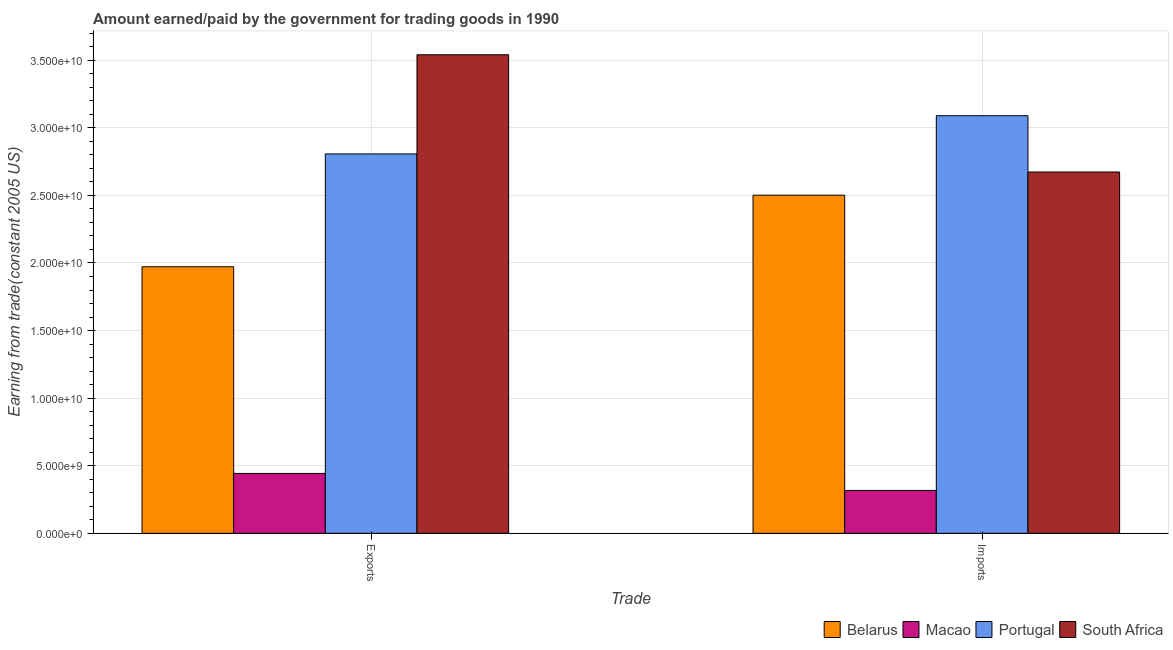How many different coloured bars are there?
Your response must be concise. 4. How many groups of bars are there?
Offer a very short reply. 2. Are the number of bars per tick equal to the number of legend labels?
Keep it short and to the point. Yes. Are the number of bars on each tick of the X-axis equal?
Give a very brief answer. Yes. How many bars are there on the 1st tick from the left?
Offer a very short reply. 4. What is the label of the 2nd group of bars from the left?
Keep it short and to the point. Imports. What is the amount paid for imports in Belarus?
Offer a very short reply. 2.50e+1. Across all countries, what is the maximum amount paid for imports?
Make the answer very short. 3.09e+1. Across all countries, what is the minimum amount paid for imports?
Offer a very short reply. 3.17e+09. In which country was the amount paid for imports minimum?
Make the answer very short. Macao. What is the total amount paid for imports in the graph?
Give a very brief answer. 8.58e+1. What is the difference between the amount paid for imports in Portugal and that in Belarus?
Offer a terse response. 5.88e+09. What is the difference between the amount paid for imports in Belarus and the amount earned from exports in Portugal?
Provide a succinct answer. -3.05e+09. What is the average amount earned from exports per country?
Provide a succinct answer. 2.19e+1. What is the difference between the amount earned from exports and amount paid for imports in Macao?
Provide a short and direct response. 1.26e+09. What is the ratio of the amount earned from exports in Belarus to that in South Africa?
Provide a succinct answer. 0.56. Is the amount paid for imports in South Africa less than that in Macao?
Make the answer very short. No. In how many countries, is the amount earned from exports greater than the average amount earned from exports taken over all countries?
Your response must be concise. 2. What does the 4th bar from the left in Imports represents?
Your answer should be compact. South Africa. What does the 2nd bar from the right in Exports represents?
Your response must be concise. Portugal. How many countries are there in the graph?
Ensure brevity in your answer.  4. What is the difference between two consecutive major ticks on the Y-axis?
Give a very brief answer. 5.00e+09. Does the graph contain grids?
Your answer should be compact. Yes. Where does the legend appear in the graph?
Your answer should be compact. Bottom right. How many legend labels are there?
Ensure brevity in your answer.  4. How are the legend labels stacked?
Offer a terse response. Horizontal. What is the title of the graph?
Provide a short and direct response. Amount earned/paid by the government for trading goods in 1990. What is the label or title of the X-axis?
Your answer should be very brief. Trade. What is the label or title of the Y-axis?
Provide a succinct answer. Earning from trade(constant 2005 US). What is the Earning from trade(constant 2005 US) in Belarus in Exports?
Keep it short and to the point. 1.97e+1. What is the Earning from trade(constant 2005 US) in Macao in Exports?
Make the answer very short. 4.43e+09. What is the Earning from trade(constant 2005 US) of Portugal in Exports?
Offer a terse response. 2.81e+1. What is the Earning from trade(constant 2005 US) of South Africa in Exports?
Offer a terse response. 3.54e+1. What is the Earning from trade(constant 2005 US) in Belarus in Imports?
Make the answer very short. 2.50e+1. What is the Earning from trade(constant 2005 US) of Macao in Imports?
Offer a very short reply. 3.17e+09. What is the Earning from trade(constant 2005 US) of Portugal in Imports?
Make the answer very short. 3.09e+1. What is the Earning from trade(constant 2005 US) of South Africa in Imports?
Provide a short and direct response. 2.67e+1. Across all Trade, what is the maximum Earning from trade(constant 2005 US) in Belarus?
Your answer should be very brief. 2.50e+1. Across all Trade, what is the maximum Earning from trade(constant 2005 US) of Macao?
Keep it short and to the point. 4.43e+09. Across all Trade, what is the maximum Earning from trade(constant 2005 US) of Portugal?
Keep it short and to the point. 3.09e+1. Across all Trade, what is the maximum Earning from trade(constant 2005 US) of South Africa?
Make the answer very short. 3.54e+1. Across all Trade, what is the minimum Earning from trade(constant 2005 US) of Belarus?
Give a very brief answer. 1.97e+1. Across all Trade, what is the minimum Earning from trade(constant 2005 US) of Macao?
Provide a succinct answer. 3.17e+09. Across all Trade, what is the minimum Earning from trade(constant 2005 US) in Portugal?
Give a very brief answer. 2.81e+1. Across all Trade, what is the minimum Earning from trade(constant 2005 US) of South Africa?
Your response must be concise. 2.67e+1. What is the total Earning from trade(constant 2005 US) in Belarus in the graph?
Make the answer very short. 4.47e+1. What is the total Earning from trade(constant 2005 US) in Macao in the graph?
Give a very brief answer. 7.60e+09. What is the total Earning from trade(constant 2005 US) of Portugal in the graph?
Your response must be concise. 5.90e+1. What is the total Earning from trade(constant 2005 US) in South Africa in the graph?
Provide a short and direct response. 6.21e+1. What is the difference between the Earning from trade(constant 2005 US) in Belarus in Exports and that in Imports?
Give a very brief answer. -5.30e+09. What is the difference between the Earning from trade(constant 2005 US) of Macao in Exports and that in Imports?
Keep it short and to the point. 1.26e+09. What is the difference between the Earning from trade(constant 2005 US) of Portugal in Exports and that in Imports?
Your answer should be very brief. -2.83e+09. What is the difference between the Earning from trade(constant 2005 US) of South Africa in Exports and that in Imports?
Ensure brevity in your answer.  8.67e+09. What is the difference between the Earning from trade(constant 2005 US) in Belarus in Exports and the Earning from trade(constant 2005 US) in Macao in Imports?
Offer a very short reply. 1.65e+1. What is the difference between the Earning from trade(constant 2005 US) in Belarus in Exports and the Earning from trade(constant 2005 US) in Portugal in Imports?
Your answer should be compact. -1.12e+1. What is the difference between the Earning from trade(constant 2005 US) in Belarus in Exports and the Earning from trade(constant 2005 US) in South Africa in Imports?
Offer a terse response. -7.01e+09. What is the difference between the Earning from trade(constant 2005 US) in Macao in Exports and the Earning from trade(constant 2005 US) in Portugal in Imports?
Give a very brief answer. -2.65e+1. What is the difference between the Earning from trade(constant 2005 US) of Macao in Exports and the Earning from trade(constant 2005 US) of South Africa in Imports?
Your answer should be very brief. -2.23e+1. What is the difference between the Earning from trade(constant 2005 US) in Portugal in Exports and the Earning from trade(constant 2005 US) in South Africa in Imports?
Offer a terse response. 1.34e+09. What is the average Earning from trade(constant 2005 US) in Belarus per Trade?
Ensure brevity in your answer.  2.24e+1. What is the average Earning from trade(constant 2005 US) of Macao per Trade?
Provide a succinct answer. 3.80e+09. What is the average Earning from trade(constant 2005 US) in Portugal per Trade?
Offer a terse response. 2.95e+1. What is the average Earning from trade(constant 2005 US) of South Africa per Trade?
Offer a very short reply. 3.11e+1. What is the difference between the Earning from trade(constant 2005 US) of Belarus and Earning from trade(constant 2005 US) of Macao in Exports?
Your answer should be very brief. 1.53e+1. What is the difference between the Earning from trade(constant 2005 US) of Belarus and Earning from trade(constant 2005 US) of Portugal in Exports?
Provide a succinct answer. -8.35e+09. What is the difference between the Earning from trade(constant 2005 US) in Belarus and Earning from trade(constant 2005 US) in South Africa in Exports?
Provide a succinct answer. -1.57e+1. What is the difference between the Earning from trade(constant 2005 US) of Macao and Earning from trade(constant 2005 US) of Portugal in Exports?
Your answer should be compact. -2.36e+1. What is the difference between the Earning from trade(constant 2005 US) of Macao and Earning from trade(constant 2005 US) of South Africa in Exports?
Your answer should be very brief. -3.10e+1. What is the difference between the Earning from trade(constant 2005 US) of Portugal and Earning from trade(constant 2005 US) of South Africa in Exports?
Your answer should be very brief. -7.34e+09. What is the difference between the Earning from trade(constant 2005 US) in Belarus and Earning from trade(constant 2005 US) in Macao in Imports?
Your response must be concise. 2.18e+1. What is the difference between the Earning from trade(constant 2005 US) of Belarus and Earning from trade(constant 2005 US) of Portugal in Imports?
Your answer should be compact. -5.88e+09. What is the difference between the Earning from trade(constant 2005 US) of Belarus and Earning from trade(constant 2005 US) of South Africa in Imports?
Ensure brevity in your answer.  -1.71e+09. What is the difference between the Earning from trade(constant 2005 US) of Macao and Earning from trade(constant 2005 US) of Portugal in Imports?
Keep it short and to the point. -2.77e+1. What is the difference between the Earning from trade(constant 2005 US) in Macao and Earning from trade(constant 2005 US) in South Africa in Imports?
Ensure brevity in your answer.  -2.36e+1. What is the difference between the Earning from trade(constant 2005 US) of Portugal and Earning from trade(constant 2005 US) of South Africa in Imports?
Provide a short and direct response. 4.16e+09. What is the ratio of the Earning from trade(constant 2005 US) of Belarus in Exports to that in Imports?
Make the answer very short. 0.79. What is the ratio of the Earning from trade(constant 2005 US) of Macao in Exports to that in Imports?
Your response must be concise. 1.4. What is the ratio of the Earning from trade(constant 2005 US) in Portugal in Exports to that in Imports?
Your answer should be very brief. 0.91. What is the ratio of the Earning from trade(constant 2005 US) in South Africa in Exports to that in Imports?
Your response must be concise. 1.32. What is the difference between the highest and the second highest Earning from trade(constant 2005 US) in Belarus?
Give a very brief answer. 5.30e+09. What is the difference between the highest and the second highest Earning from trade(constant 2005 US) in Macao?
Your answer should be compact. 1.26e+09. What is the difference between the highest and the second highest Earning from trade(constant 2005 US) of Portugal?
Give a very brief answer. 2.83e+09. What is the difference between the highest and the second highest Earning from trade(constant 2005 US) of South Africa?
Keep it short and to the point. 8.67e+09. What is the difference between the highest and the lowest Earning from trade(constant 2005 US) of Belarus?
Your answer should be compact. 5.30e+09. What is the difference between the highest and the lowest Earning from trade(constant 2005 US) of Macao?
Give a very brief answer. 1.26e+09. What is the difference between the highest and the lowest Earning from trade(constant 2005 US) of Portugal?
Make the answer very short. 2.83e+09. What is the difference between the highest and the lowest Earning from trade(constant 2005 US) of South Africa?
Your response must be concise. 8.67e+09. 